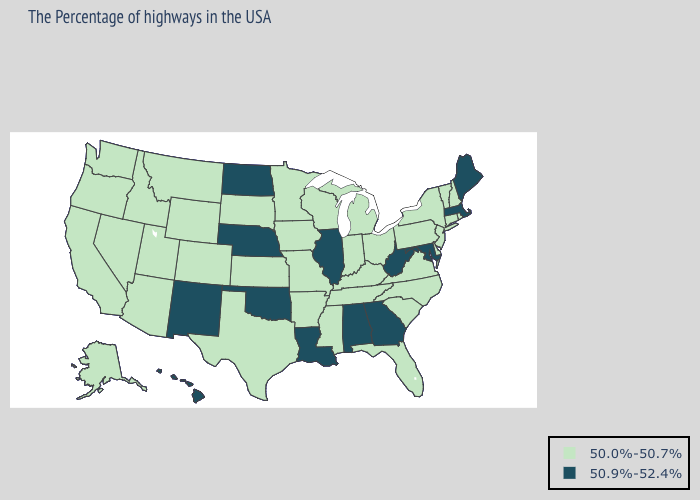Which states have the lowest value in the Northeast?
Quick response, please. Rhode Island, New Hampshire, Vermont, Connecticut, New York, New Jersey, Pennsylvania. Name the states that have a value in the range 50.0%-50.7%?
Give a very brief answer. Rhode Island, New Hampshire, Vermont, Connecticut, New York, New Jersey, Delaware, Pennsylvania, Virginia, North Carolina, South Carolina, Ohio, Florida, Michigan, Kentucky, Indiana, Tennessee, Wisconsin, Mississippi, Missouri, Arkansas, Minnesota, Iowa, Kansas, Texas, South Dakota, Wyoming, Colorado, Utah, Montana, Arizona, Idaho, Nevada, California, Washington, Oregon, Alaska. Is the legend a continuous bar?
Write a very short answer. No. What is the highest value in the Northeast ?
Be succinct. 50.9%-52.4%. Which states hav the highest value in the West?
Write a very short answer. New Mexico, Hawaii. What is the highest value in the USA?
Give a very brief answer. 50.9%-52.4%. Does Maryland have the same value as Georgia?
Write a very short answer. Yes. Does Iowa have a lower value than Oregon?
Give a very brief answer. No. What is the value of Pennsylvania?
Give a very brief answer. 50.0%-50.7%. What is the lowest value in the USA?
Concise answer only. 50.0%-50.7%. Does West Virginia have the highest value in the South?
Short answer required. Yes. What is the highest value in the Northeast ?
Keep it brief. 50.9%-52.4%. What is the value of Oklahoma?
Be succinct. 50.9%-52.4%. Name the states that have a value in the range 50.9%-52.4%?
Quick response, please. Maine, Massachusetts, Maryland, West Virginia, Georgia, Alabama, Illinois, Louisiana, Nebraska, Oklahoma, North Dakota, New Mexico, Hawaii. 